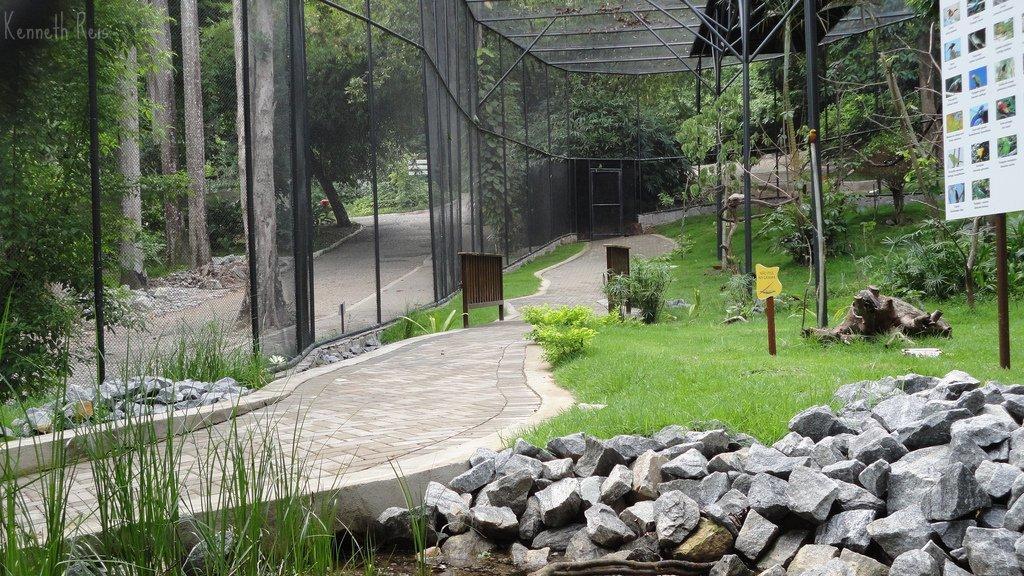In one or two sentences, can you explain what this image depicts? In this picture we can see stones, boards, grass, poles, paths, fence and in the background we can see trees. 